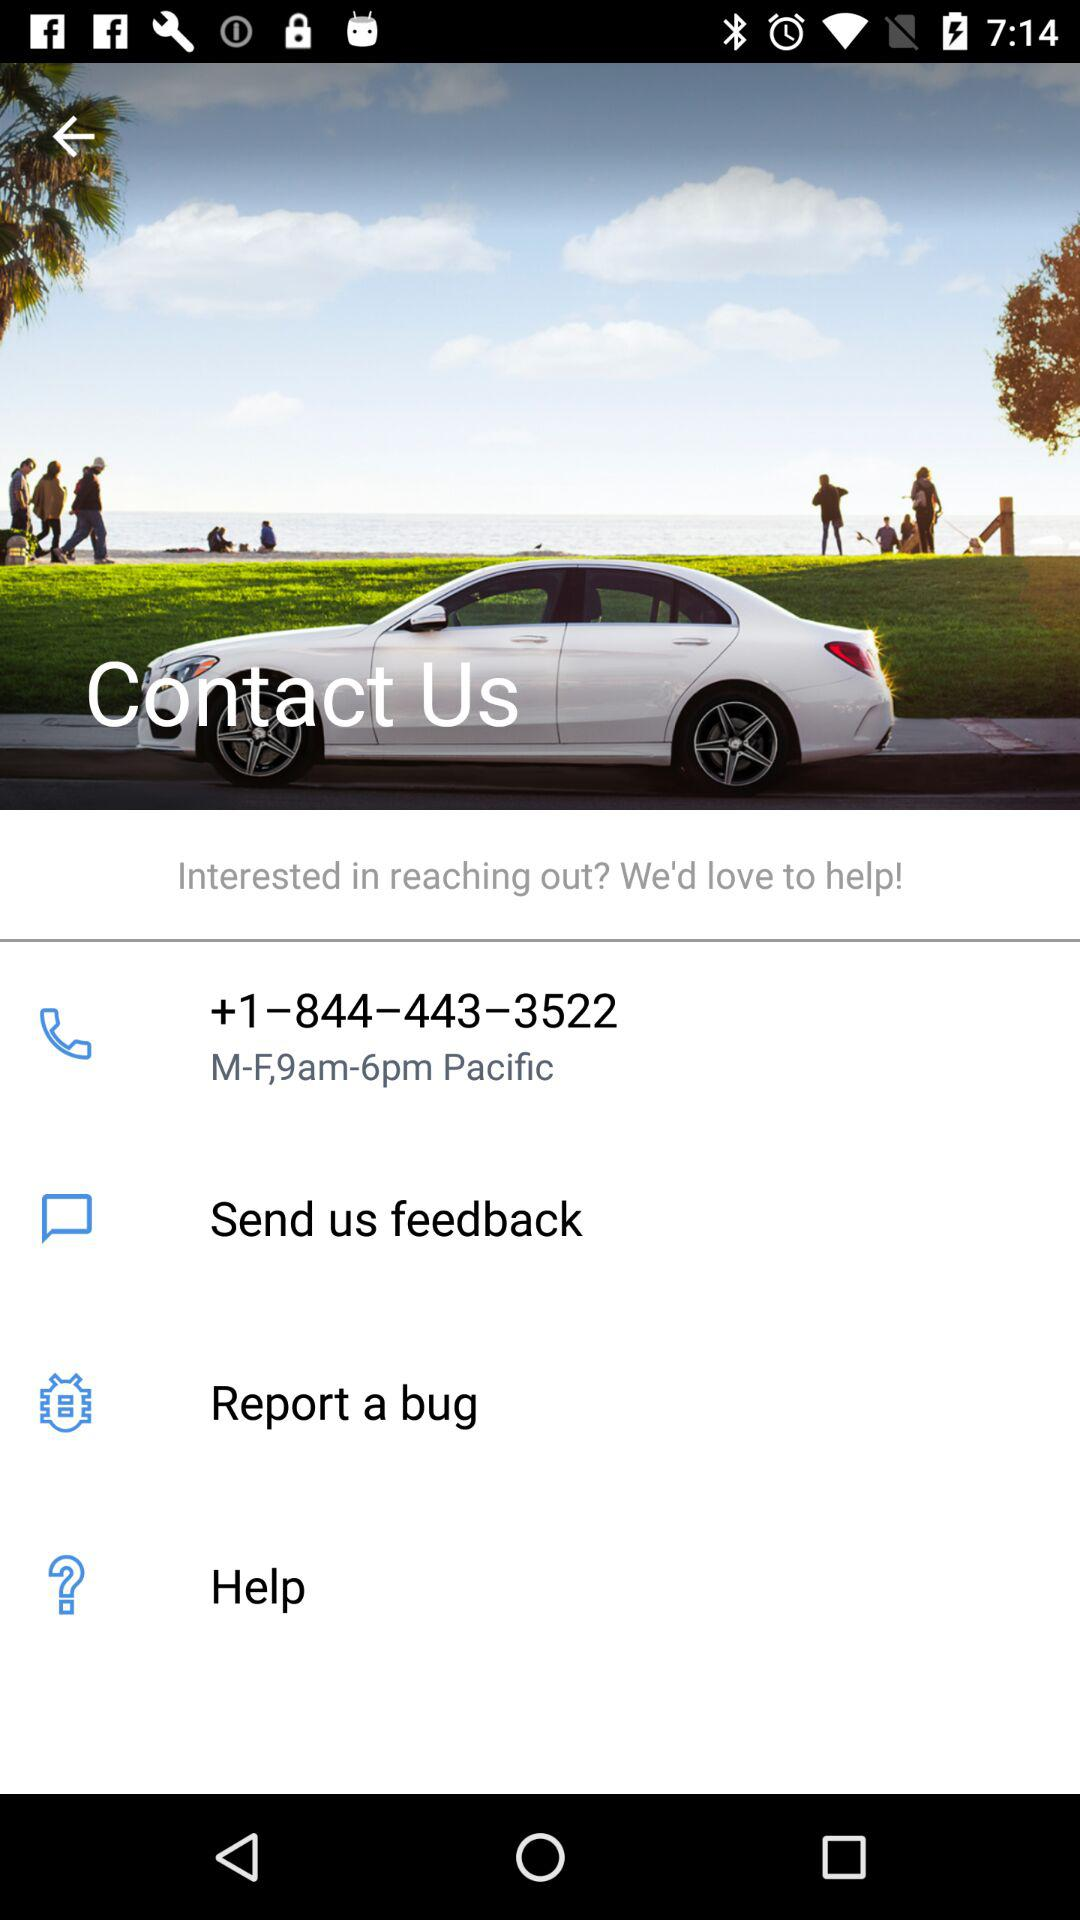How many contact options are there?
Answer the question using a single word or phrase. 4 